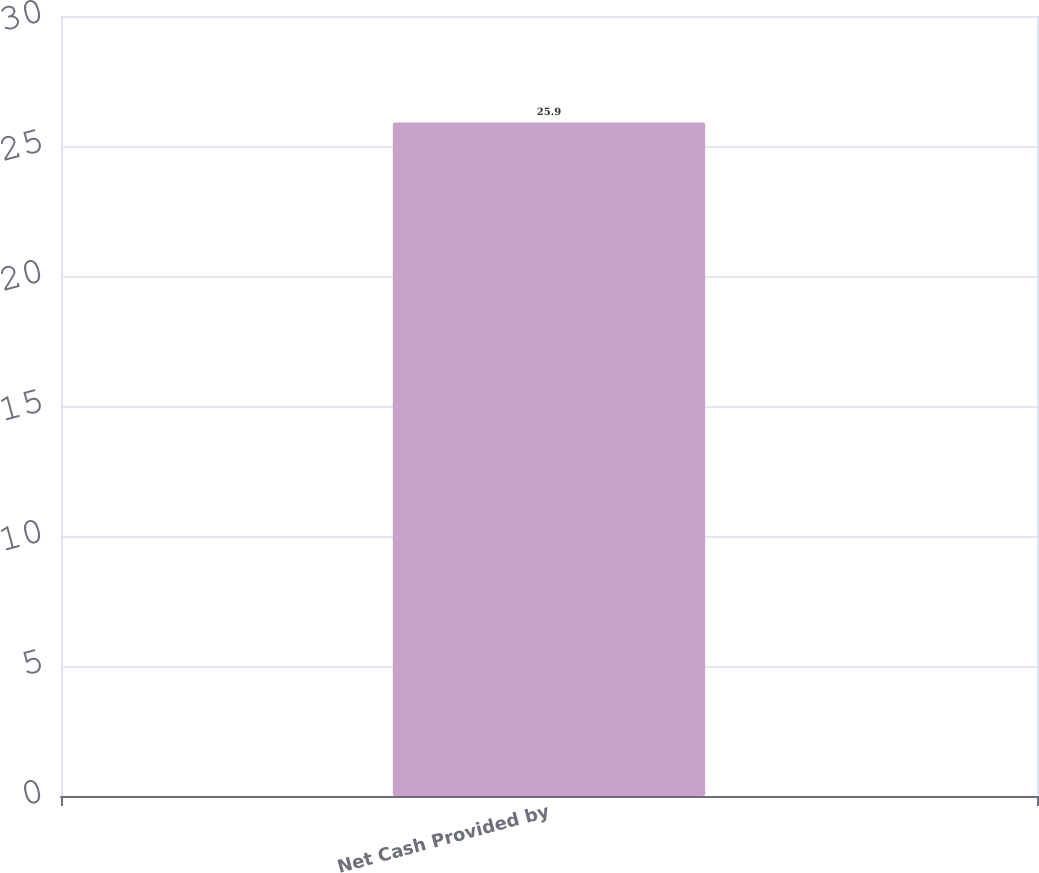<chart> <loc_0><loc_0><loc_500><loc_500><bar_chart><fcel>Net Cash Provided by<nl><fcel>25.9<nl></chart> 